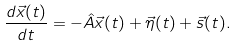Convert formula to latex. <formula><loc_0><loc_0><loc_500><loc_500>\frac { d \vec { x } ( t ) } { d t } = - \hat { A } \vec { x } ( t ) + \vec { \eta } ( t ) + \vec { s } ( t ) .</formula> 